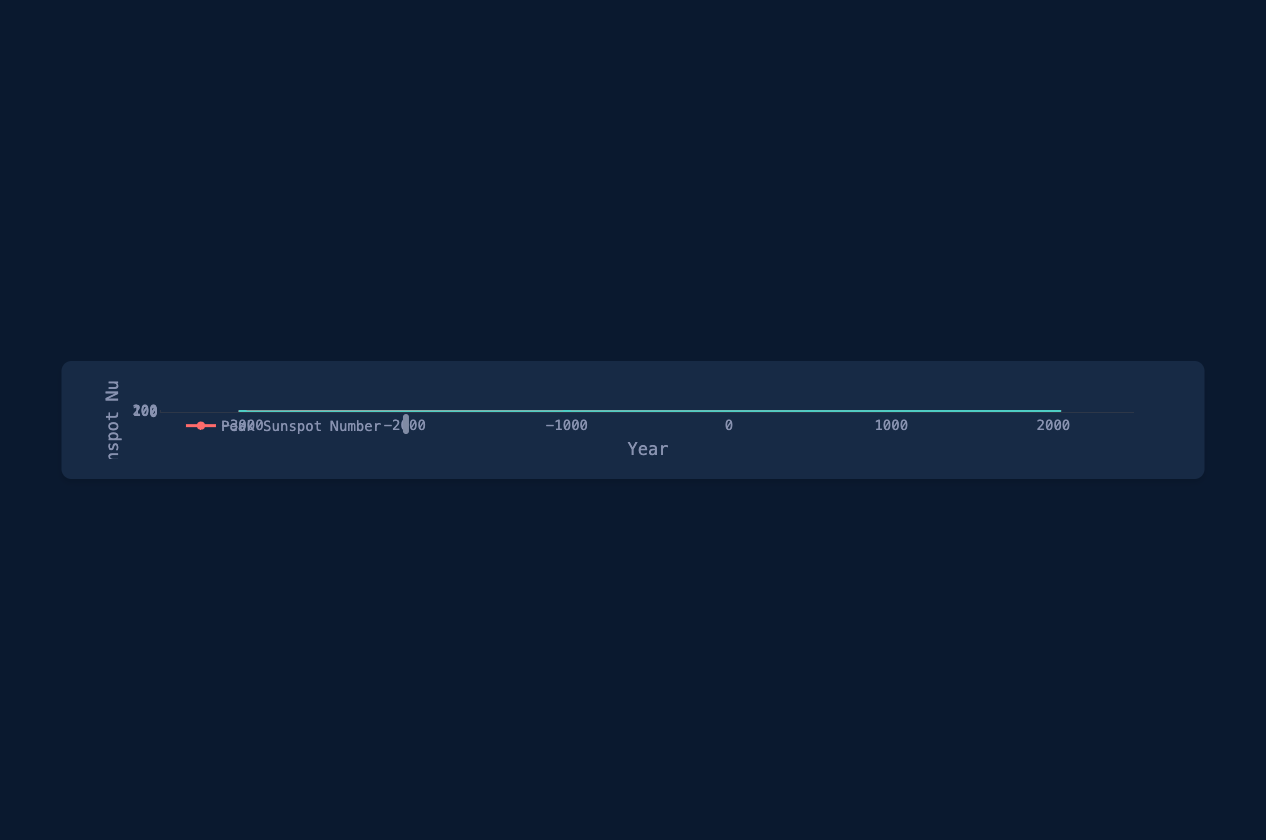What is the peak sunspot number in the year 1950? Locate the data point on the curve for the year 1950 and observe the corresponding peak sunspot number.
Answer: 200 By how much did the peak sunspot number increase from the year -3000 to the year 2023? Find the peak sunspot numbers for the years -3000 and 2023: 40 and 230 respectively. Calculate the difference: 230 - 40.
Answer: 190 Which year saw the higher trough sunspot number, 1600 or 1700? Compare the trough sunspot numbers for the years 1600 (38) and 1700 (40).
Answer: 1700 What is the sum of the peak sunspot numbers for the years 1500 and 1800? Locate the peak sunspot numbers for the years 1500 (80) and 1800 (145). Sum these numbers: 80 + 145.
Answer: 225 What is the difference between the peak and trough sunspot numbers in the year 2000? Find the peak and trough sunspot numbers for the year 2000: 220 and 65 respectively. Subtract the trough number from the peak number: 220 - 65.
Answer: 155 In which year did the peak sunspot number first exceed 100? Examine the curve to find the first year where the peak sunspot number is greater than 100, which occurs in the year 1700.
Answer: 1700 Which line represents the trough sunspot numbers and what color is it? Identify the two lines and their colors; the trough sunspot numbers are represented by the line in green color.
Answer: Green What is the average trough sunspot number between the years 1500 and 1900 inclusive? Extract the trough numbers for the years 1500 (35), 1600 (38), 1700 (40), 1750 (43), 1800 (47), and 1900 (55). Sum these numbers: 35 + 38 + 40 + 43 + 47 + 55 = 258. Divide by the number of years (6): 258 / 6.
Answer: 43 What is the median peak sunspot number from the following years: -3000, -1000, 500, and 1000? Identify the peak numbers for the specified years: 40, 50, 60, 70. Arrange them in order: 40, 50, 60, 70. The median is the average of the two middle numbers: (50 + 60) / 2.
Answer: 55 How does the peak sunspot number trend from the year 1000 to 2000? Observe the trend of peak sunspot numbers from 1000 to 2000. These years see increases consistently from 70 in 1000 to 220 in 2000, indicating an upward trend.
Answer: Upward trend 